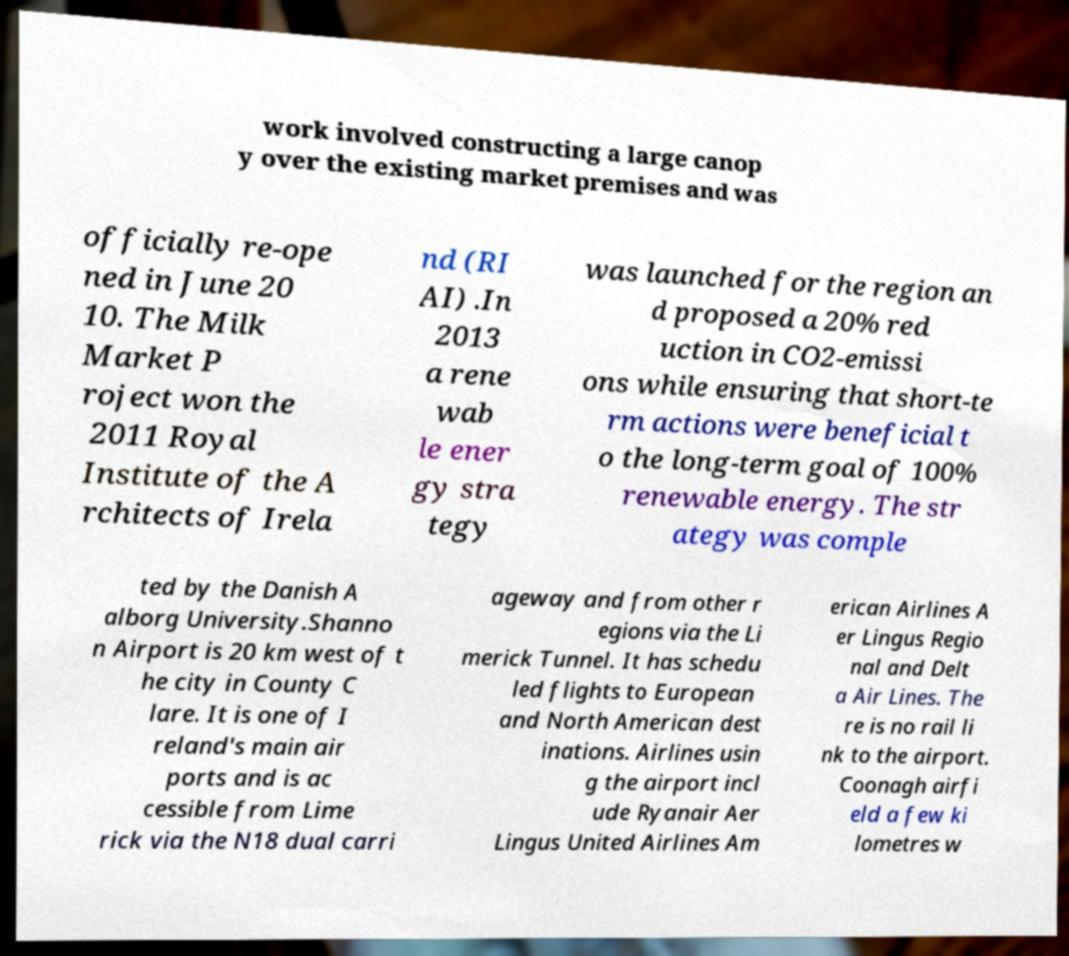Can you read and provide the text displayed in the image?This photo seems to have some interesting text. Can you extract and type it out for me? work involved constructing a large canop y over the existing market premises and was officially re-ope ned in June 20 10. The Milk Market P roject won the 2011 Royal Institute of the A rchitects of Irela nd (RI AI) .In 2013 a rene wab le ener gy stra tegy was launched for the region an d proposed a 20% red uction in CO2-emissi ons while ensuring that short-te rm actions were beneficial t o the long-term goal of 100% renewable energy. The str ategy was comple ted by the Danish A alborg University.Shanno n Airport is 20 km west of t he city in County C lare. It is one of I reland's main air ports and is ac cessible from Lime rick via the N18 dual carri ageway and from other r egions via the Li merick Tunnel. It has schedu led flights to European and North American dest inations. Airlines usin g the airport incl ude Ryanair Aer Lingus United Airlines Am erican Airlines A er Lingus Regio nal and Delt a Air Lines. The re is no rail li nk to the airport. Coonagh airfi eld a few ki lometres w 